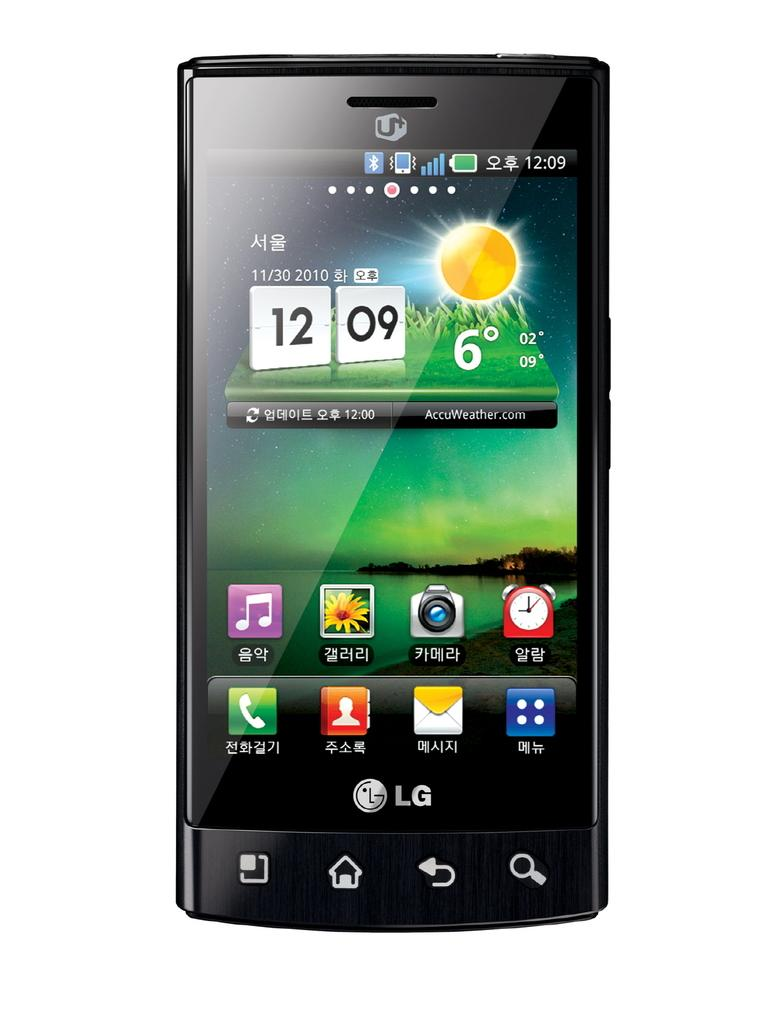<image>
Offer a succinct explanation of the picture presented. The front os a LG mobile phone with several icons and the time 12:09 displayed. 